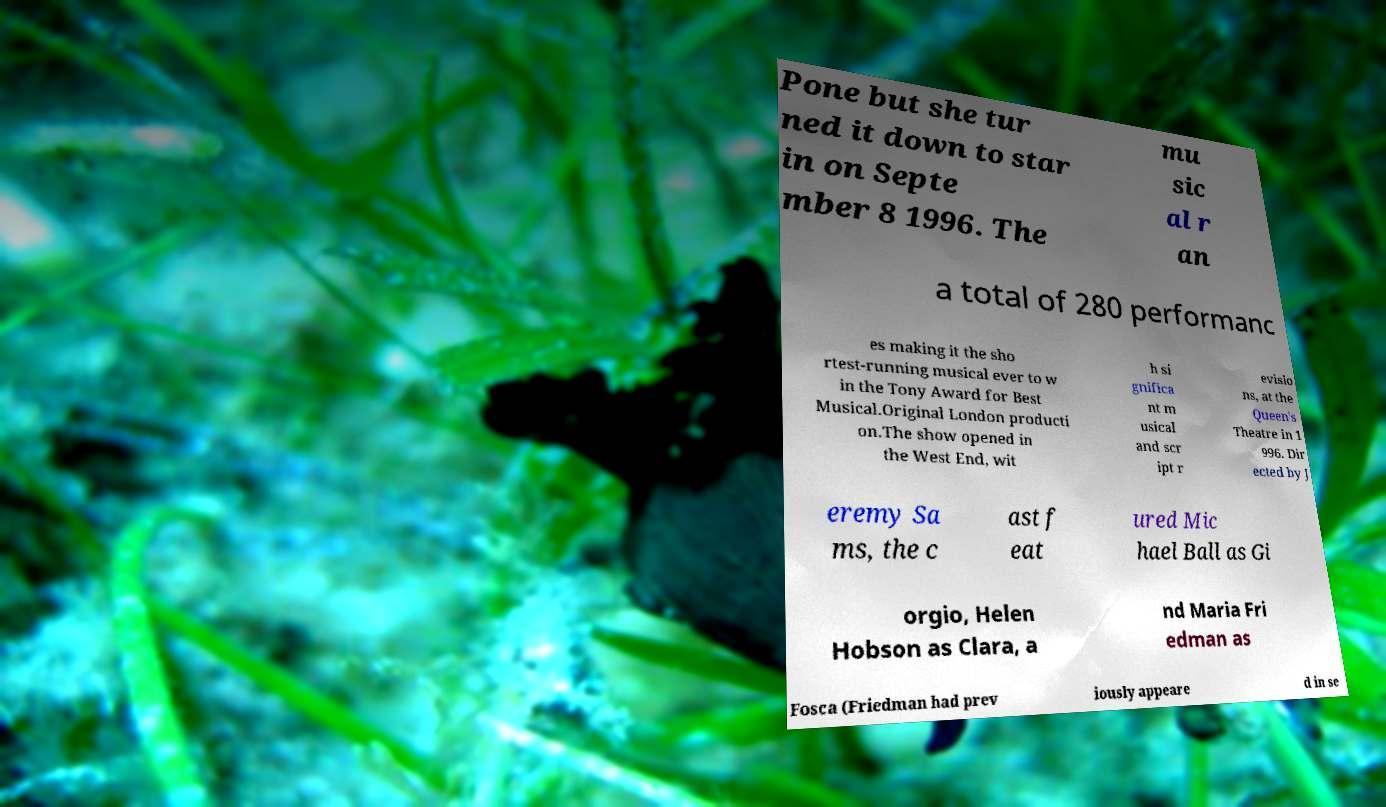Please identify and transcribe the text found in this image. Pone but she tur ned it down to star in on Septe mber 8 1996. The mu sic al r an a total of 280 performanc es making it the sho rtest-running musical ever to w in the Tony Award for Best Musical.Original London producti on.The show opened in the West End, wit h si gnifica nt m usical and scr ipt r evisio ns, at the Queen's Theatre in 1 996. Dir ected by J eremy Sa ms, the c ast f eat ured Mic hael Ball as Gi orgio, Helen Hobson as Clara, a nd Maria Fri edman as Fosca (Friedman had prev iously appeare d in se 